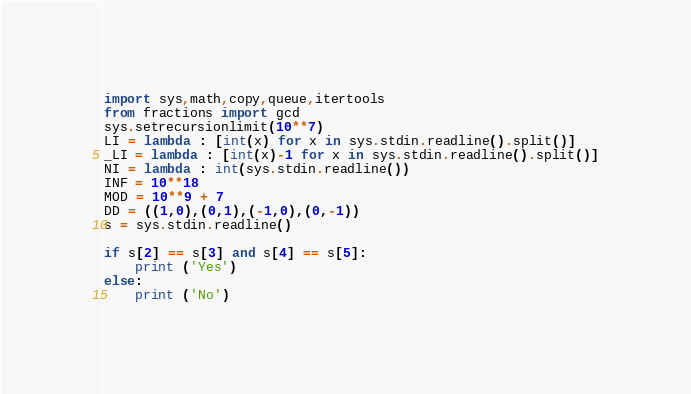<code> <loc_0><loc_0><loc_500><loc_500><_Python_>import sys,math,copy,queue,itertools
from fractions import gcd
sys.setrecursionlimit(10**7)
LI = lambda : [int(x) for x in sys.stdin.readline().split()]
_LI = lambda : [int(x)-1 for x in sys.stdin.readline().split()]
NI = lambda : int(sys.stdin.readline())
INF = 10**18
MOD = 10**9 + 7
DD = ((1,0),(0,1),(-1,0),(0,-1))
s = sys.stdin.readline()

if s[2] == s[3] and s[4] == s[5]:
    print ('Yes')
else:
    print ('No')</code> 